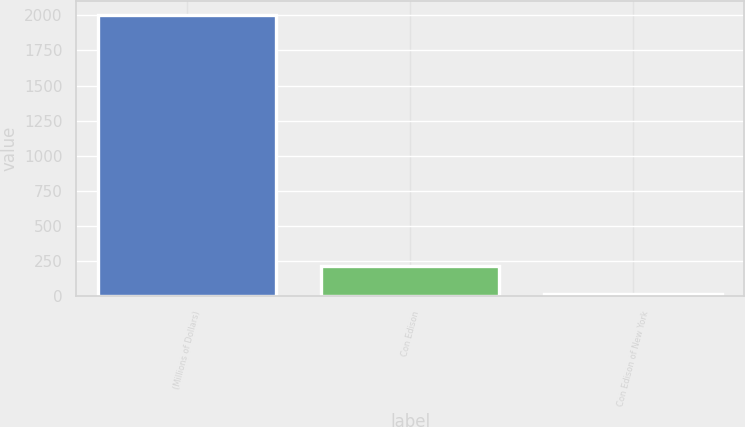<chart> <loc_0><loc_0><loc_500><loc_500><bar_chart><fcel>(Millions of Dollars)<fcel>Con Edison<fcel>Con Edison of New York<nl><fcel>2003<fcel>215.6<fcel>17<nl></chart> 